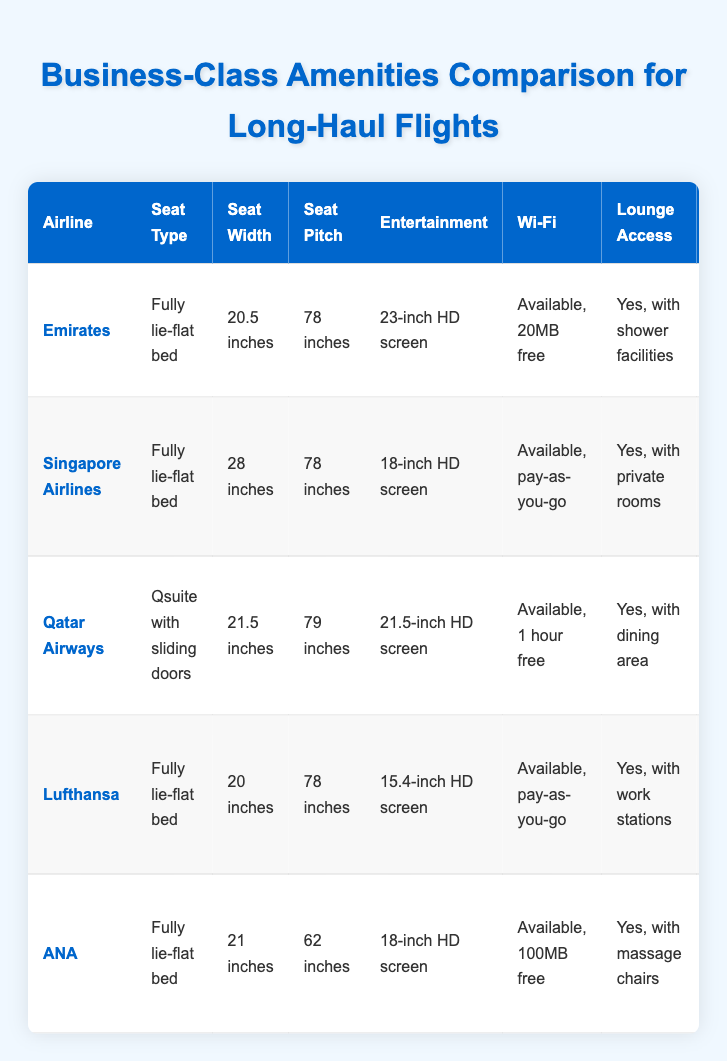What is the seat width of Singapore Airlines? The seat width for Singapore Airlines is listed in the "Seat Width" column, which shows "28 inches."
Answer: 28 inches Which airline has the largest seat width among the listed airlines? From reviewing the "Seat Width" column, Singapore Airlines has the largest seat width at "28 inches."
Answer: Singapore Airlines Do all airlines provide real-time weather updates at their destination? By checking the "Weather Updates" column, only Emirates provides real-time weather reports; Qatar Airways offers a live weather radar, and others give forecasts on personal devices. Therefore, not all airlines provide real-time updates.
Answer: No Which airlines provide pajamas on long flights? The "Pajamas" column indicates pajamas are provided by Emirates, Singapore Airlines, Qatar Airways, and ANA on flights over specific durations. So four airlines offer pajamas.
Answer: Four airlines What is the average seat pitch among the airlines? The seat pitches are 78, 78, 79, 78, and 62 inches, respectively. Adding them gives 395 inches. Dividing by the total number of airlines (5) gives an average seat pitch of 79 inches.
Answer: 79 inches Which airline offers a dedicated lounge with shower facilities? The "Lounge Access" column states that Emirates offers lounge access with shower facilities. Other airlines mention different kinds of access, but Emirates is the only one with showers.
Answer: Emirates Does Lufthansa have an onboard bar? Looking at the "Onboard Bar" column, it is clear that Lufthansa does not have an onboard bar as it is marked "No."
Answer: No Which airline offers a dine-on-demand service? The "Dining" column shows that Qatar Airways offers a "Dine-on-demand service." Other airlines have different dining options, but only Qatar Airways has this specific service.
Answer: Qatar Airways Which airline provides the longest seat pitch? By checking the "Seat Pitch" column, Qatar Airways has the longest seat pitch listed as "79 inches," which is greater than the others.
Answer: Qatar Airways 